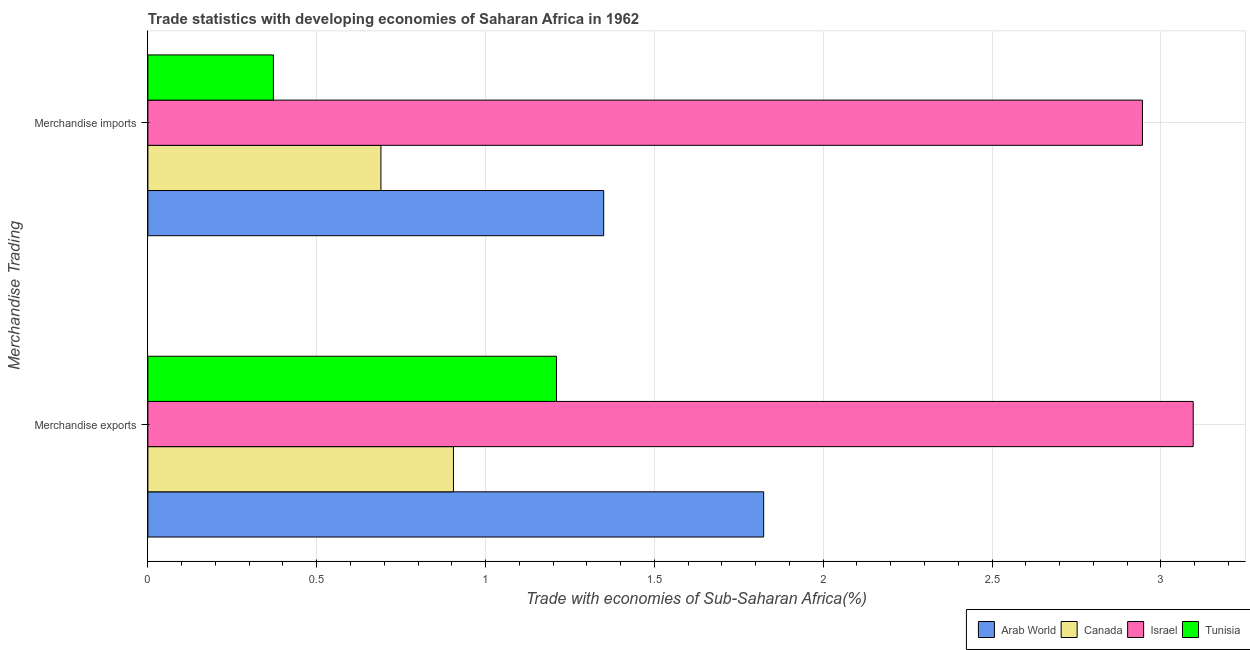How many different coloured bars are there?
Your response must be concise. 4. How many groups of bars are there?
Provide a short and direct response. 2. Are the number of bars on each tick of the Y-axis equal?
Make the answer very short. Yes. How many bars are there on the 1st tick from the bottom?
Provide a short and direct response. 4. What is the merchandise imports in Tunisia?
Ensure brevity in your answer.  0.37. Across all countries, what is the maximum merchandise exports?
Provide a succinct answer. 3.1. Across all countries, what is the minimum merchandise imports?
Give a very brief answer. 0.37. In which country was the merchandise exports maximum?
Provide a short and direct response. Israel. In which country was the merchandise imports minimum?
Your answer should be compact. Tunisia. What is the total merchandise imports in the graph?
Offer a very short reply. 5.36. What is the difference between the merchandise imports in Arab World and that in Canada?
Offer a very short reply. 0.66. What is the difference between the merchandise exports in Canada and the merchandise imports in Israel?
Keep it short and to the point. -2.04. What is the average merchandise imports per country?
Your answer should be very brief. 1.34. What is the difference between the merchandise imports and merchandise exports in Israel?
Give a very brief answer. -0.15. What is the ratio of the merchandise exports in Arab World to that in Tunisia?
Your answer should be compact. 1.51. In how many countries, is the merchandise exports greater than the average merchandise exports taken over all countries?
Your answer should be very brief. 2. What does the 4th bar from the top in Merchandise imports represents?
Your answer should be very brief. Arab World. What does the 3rd bar from the bottom in Merchandise exports represents?
Give a very brief answer. Israel. Are the values on the major ticks of X-axis written in scientific E-notation?
Provide a short and direct response. No. How are the legend labels stacked?
Your answer should be compact. Horizontal. What is the title of the graph?
Your response must be concise. Trade statistics with developing economies of Saharan Africa in 1962. Does "Cabo Verde" appear as one of the legend labels in the graph?
Provide a succinct answer. No. What is the label or title of the X-axis?
Provide a succinct answer. Trade with economies of Sub-Saharan Africa(%). What is the label or title of the Y-axis?
Make the answer very short. Merchandise Trading. What is the Trade with economies of Sub-Saharan Africa(%) in Arab World in Merchandise exports?
Keep it short and to the point. 1.82. What is the Trade with economies of Sub-Saharan Africa(%) of Canada in Merchandise exports?
Your answer should be compact. 0.9. What is the Trade with economies of Sub-Saharan Africa(%) of Israel in Merchandise exports?
Offer a very short reply. 3.1. What is the Trade with economies of Sub-Saharan Africa(%) in Tunisia in Merchandise exports?
Keep it short and to the point. 1.21. What is the Trade with economies of Sub-Saharan Africa(%) in Arab World in Merchandise imports?
Offer a very short reply. 1.35. What is the Trade with economies of Sub-Saharan Africa(%) in Canada in Merchandise imports?
Your response must be concise. 0.69. What is the Trade with economies of Sub-Saharan Africa(%) of Israel in Merchandise imports?
Your answer should be very brief. 2.95. What is the Trade with economies of Sub-Saharan Africa(%) of Tunisia in Merchandise imports?
Keep it short and to the point. 0.37. Across all Merchandise Trading, what is the maximum Trade with economies of Sub-Saharan Africa(%) in Arab World?
Offer a very short reply. 1.82. Across all Merchandise Trading, what is the maximum Trade with economies of Sub-Saharan Africa(%) in Canada?
Ensure brevity in your answer.  0.9. Across all Merchandise Trading, what is the maximum Trade with economies of Sub-Saharan Africa(%) in Israel?
Ensure brevity in your answer.  3.1. Across all Merchandise Trading, what is the maximum Trade with economies of Sub-Saharan Africa(%) of Tunisia?
Provide a short and direct response. 1.21. Across all Merchandise Trading, what is the minimum Trade with economies of Sub-Saharan Africa(%) of Arab World?
Provide a succinct answer. 1.35. Across all Merchandise Trading, what is the minimum Trade with economies of Sub-Saharan Africa(%) of Canada?
Your response must be concise. 0.69. Across all Merchandise Trading, what is the minimum Trade with economies of Sub-Saharan Africa(%) of Israel?
Offer a very short reply. 2.95. Across all Merchandise Trading, what is the minimum Trade with economies of Sub-Saharan Africa(%) in Tunisia?
Make the answer very short. 0.37. What is the total Trade with economies of Sub-Saharan Africa(%) of Arab World in the graph?
Your response must be concise. 3.17. What is the total Trade with economies of Sub-Saharan Africa(%) in Canada in the graph?
Your response must be concise. 1.6. What is the total Trade with economies of Sub-Saharan Africa(%) of Israel in the graph?
Keep it short and to the point. 6.04. What is the total Trade with economies of Sub-Saharan Africa(%) in Tunisia in the graph?
Make the answer very short. 1.58. What is the difference between the Trade with economies of Sub-Saharan Africa(%) in Arab World in Merchandise exports and that in Merchandise imports?
Keep it short and to the point. 0.47. What is the difference between the Trade with economies of Sub-Saharan Africa(%) of Canada in Merchandise exports and that in Merchandise imports?
Provide a succinct answer. 0.21. What is the difference between the Trade with economies of Sub-Saharan Africa(%) in Israel in Merchandise exports and that in Merchandise imports?
Your response must be concise. 0.15. What is the difference between the Trade with economies of Sub-Saharan Africa(%) of Tunisia in Merchandise exports and that in Merchandise imports?
Make the answer very short. 0.84. What is the difference between the Trade with economies of Sub-Saharan Africa(%) in Arab World in Merchandise exports and the Trade with economies of Sub-Saharan Africa(%) in Canada in Merchandise imports?
Your answer should be very brief. 1.13. What is the difference between the Trade with economies of Sub-Saharan Africa(%) of Arab World in Merchandise exports and the Trade with economies of Sub-Saharan Africa(%) of Israel in Merchandise imports?
Keep it short and to the point. -1.12. What is the difference between the Trade with economies of Sub-Saharan Africa(%) of Arab World in Merchandise exports and the Trade with economies of Sub-Saharan Africa(%) of Tunisia in Merchandise imports?
Your answer should be compact. 1.45. What is the difference between the Trade with economies of Sub-Saharan Africa(%) of Canada in Merchandise exports and the Trade with economies of Sub-Saharan Africa(%) of Israel in Merchandise imports?
Your answer should be very brief. -2.04. What is the difference between the Trade with economies of Sub-Saharan Africa(%) in Canada in Merchandise exports and the Trade with economies of Sub-Saharan Africa(%) in Tunisia in Merchandise imports?
Make the answer very short. 0.53. What is the difference between the Trade with economies of Sub-Saharan Africa(%) in Israel in Merchandise exports and the Trade with economies of Sub-Saharan Africa(%) in Tunisia in Merchandise imports?
Provide a succinct answer. 2.72. What is the average Trade with economies of Sub-Saharan Africa(%) in Arab World per Merchandise Trading?
Offer a very short reply. 1.59. What is the average Trade with economies of Sub-Saharan Africa(%) of Canada per Merchandise Trading?
Offer a terse response. 0.8. What is the average Trade with economies of Sub-Saharan Africa(%) of Israel per Merchandise Trading?
Provide a short and direct response. 3.02. What is the average Trade with economies of Sub-Saharan Africa(%) of Tunisia per Merchandise Trading?
Make the answer very short. 0.79. What is the difference between the Trade with economies of Sub-Saharan Africa(%) of Arab World and Trade with economies of Sub-Saharan Africa(%) of Canada in Merchandise exports?
Your response must be concise. 0.92. What is the difference between the Trade with economies of Sub-Saharan Africa(%) of Arab World and Trade with economies of Sub-Saharan Africa(%) of Israel in Merchandise exports?
Make the answer very short. -1.27. What is the difference between the Trade with economies of Sub-Saharan Africa(%) of Arab World and Trade with economies of Sub-Saharan Africa(%) of Tunisia in Merchandise exports?
Give a very brief answer. 0.61. What is the difference between the Trade with economies of Sub-Saharan Africa(%) of Canada and Trade with economies of Sub-Saharan Africa(%) of Israel in Merchandise exports?
Your answer should be very brief. -2.19. What is the difference between the Trade with economies of Sub-Saharan Africa(%) of Canada and Trade with economies of Sub-Saharan Africa(%) of Tunisia in Merchandise exports?
Offer a terse response. -0.31. What is the difference between the Trade with economies of Sub-Saharan Africa(%) in Israel and Trade with economies of Sub-Saharan Africa(%) in Tunisia in Merchandise exports?
Keep it short and to the point. 1.89. What is the difference between the Trade with economies of Sub-Saharan Africa(%) in Arab World and Trade with economies of Sub-Saharan Africa(%) in Canada in Merchandise imports?
Provide a succinct answer. 0.66. What is the difference between the Trade with economies of Sub-Saharan Africa(%) of Arab World and Trade with economies of Sub-Saharan Africa(%) of Israel in Merchandise imports?
Your answer should be compact. -1.6. What is the difference between the Trade with economies of Sub-Saharan Africa(%) in Arab World and Trade with economies of Sub-Saharan Africa(%) in Tunisia in Merchandise imports?
Offer a terse response. 0.98. What is the difference between the Trade with economies of Sub-Saharan Africa(%) in Canada and Trade with economies of Sub-Saharan Africa(%) in Israel in Merchandise imports?
Your answer should be compact. -2.26. What is the difference between the Trade with economies of Sub-Saharan Africa(%) in Canada and Trade with economies of Sub-Saharan Africa(%) in Tunisia in Merchandise imports?
Your response must be concise. 0.32. What is the difference between the Trade with economies of Sub-Saharan Africa(%) in Israel and Trade with economies of Sub-Saharan Africa(%) in Tunisia in Merchandise imports?
Ensure brevity in your answer.  2.57. What is the ratio of the Trade with economies of Sub-Saharan Africa(%) of Arab World in Merchandise exports to that in Merchandise imports?
Offer a terse response. 1.35. What is the ratio of the Trade with economies of Sub-Saharan Africa(%) in Canada in Merchandise exports to that in Merchandise imports?
Make the answer very short. 1.31. What is the ratio of the Trade with economies of Sub-Saharan Africa(%) of Israel in Merchandise exports to that in Merchandise imports?
Your response must be concise. 1.05. What is the ratio of the Trade with economies of Sub-Saharan Africa(%) in Tunisia in Merchandise exports to that in Merchandise imports?
Keep it short and to the point. 3.25. What is the difference between the highest and the second highest Trade with economies of Sub-Saharan Africa(%) in Arab World?
Keep it short and to the point. 0.47. What is the difference between the highest and the second highest Trade with economies of Sub-Saharan Africa(%) of Canada?
Provide a succinct answer. 0.21. What is the difference between the highest and the second highest Trade with economies of Sub-Saharan Africa(%) of Israel?
Your response must be concise. 0.15. What is the difference between the highest and the second highest Trade with economies of Sub-Saharan Africa(%) in Tunisia?
Give a very brief answer. 0.84. What is the difference between the highest and the lowest Trade with economies of Sub-Saharan Africa(%) of Arab World?
Ensure brevity in your answer.  0.47. What is the difference between the highest and the lowest Trade with economies of Sub-Saharan Africa(%) of Canada?
Give a very brief answer. 0.21. What is the difference between the highest and the lowest Trade with economies of Sub-Saharan Africa(%) of Israel?
Ensure brevity in your answer.  0.15. What is the difference between the highest and the lowest Trade with economies of Sub-Saharan Africa(%) in Tunisia?
Make the answer very short. 0.84. 